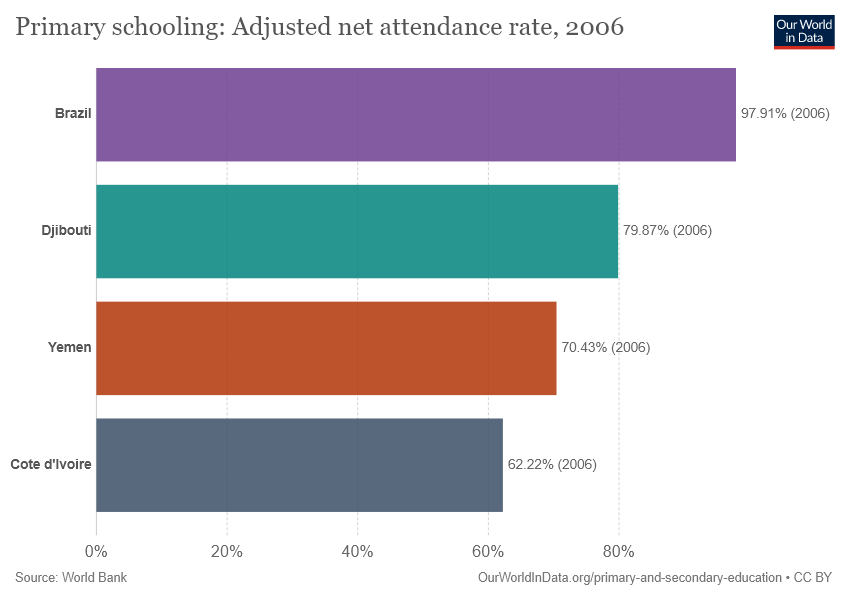Specify some key components in this picture. The average of Yemen and Brazil is 84.17. The smallest bar has a value of 62.22. 